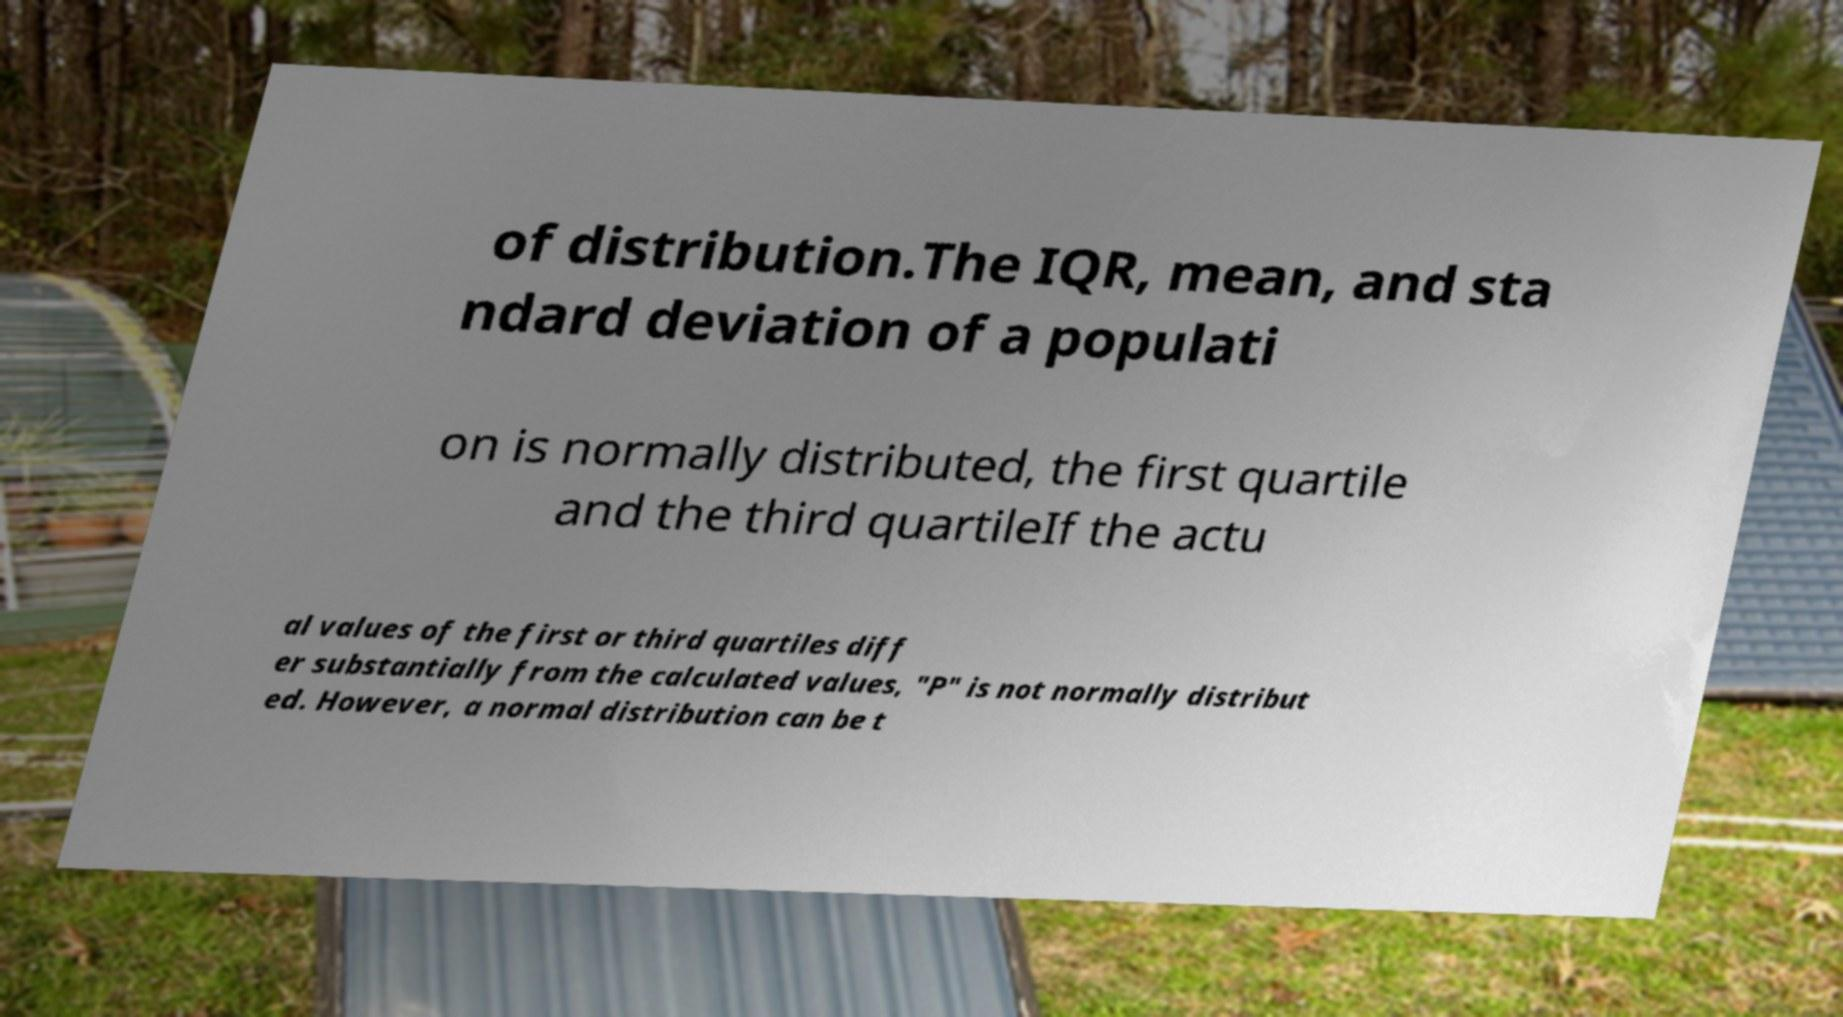I need the written content from this picture converted into text. Can you do that? of distribution.The IQR, mean, and sta ndard deviation of a populati on is normally distributed, the first quartile and the third quartileIf the actu al values of the first or third quartiles diff er substantially from the calculated values, "P" is not normally distribut ed. However, a normal distribution can be t 